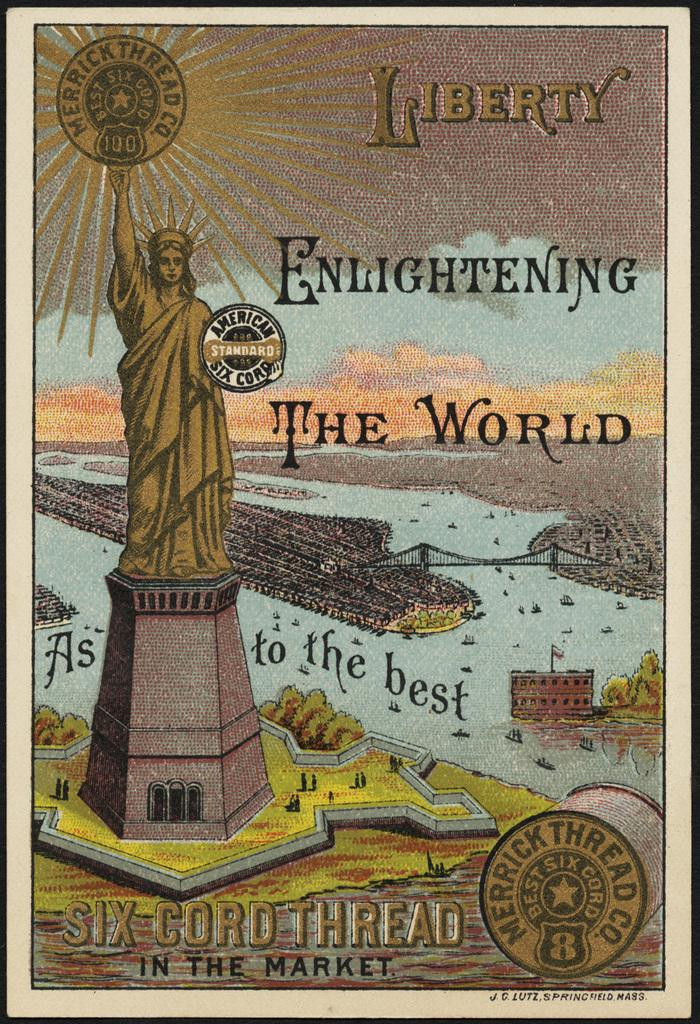<image>
Describe the image concisely. A picture says Liberty is enlightening the world. 